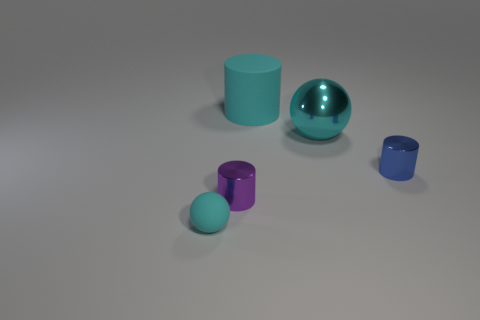Subtract all tiny purple metallic cylinders. How many cylinders are left? 2 Subtract 1 spheres. How many spheres are left? 1 Add 2 tiny metal objects. How many objects exist? 7 Subtract all blue cylinders. How many cylinders are left? 2 Subtract all purple cylinders. Subtract all cyan balls. How many cylinders are left? 2 Subtract all small cylinders. Subtract all tiny balls. How many objects are left? 2 Add 1 tiny blue metal things. How many tiny blue metal things are left? 2 Add 5 blue shiny cylinders. How many blue shiny cylinders exist? 6 Subtract 0 blue balls. How many objects are left? 5 Subtract all balls. How many objects are left? 3 